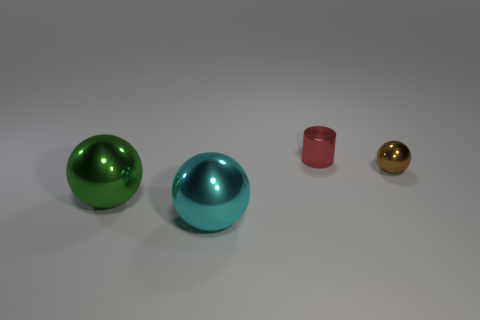How many other objects are the same color as the small ball?
Make the answer very short. 0. Are there any other things that are the same size as the cyan ball?
Give a very brief answer. Yes. What number of other objects are there of the same shape as the red object?
Ensure brevity in your answer.  0. Is the red metallic cylinder the same size as the green ball?
Provide a succinct answer. No. Are there any small shiny things?
Provide a short and direct response. Yes. Is there anything else that has the same material as the red cylinder?
Provide a succinct answer. Yes. Is there a tiny brown sphere made of the same material as the big green sphere?
Offer a very short reply. Yes. There is a brown object that is the same size as the shiny cylinder; what material is it?
Your answer should be very brief. Metal. What number of small brown metallic things have the same shape as the large cyan shiny thing?
Your answer should be very brief. 1. What size is the green sphere that is the same material as the cylinder?
Offer a very short reply. Large. 